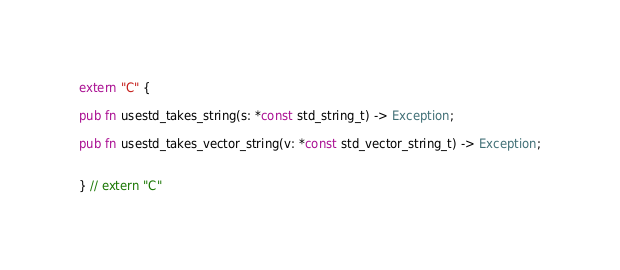Convert code to text. <code><loc_0><loc_0><loc_500><loc_500><_Rust_>extern "C" {

pub fn usestd_takes_string(s: *const std_string_t) -> Exception;

pub fn usestd_takes_vector_string(v: *const std_vector_string_t) -> Exception;


} // extern "C"
</code> 